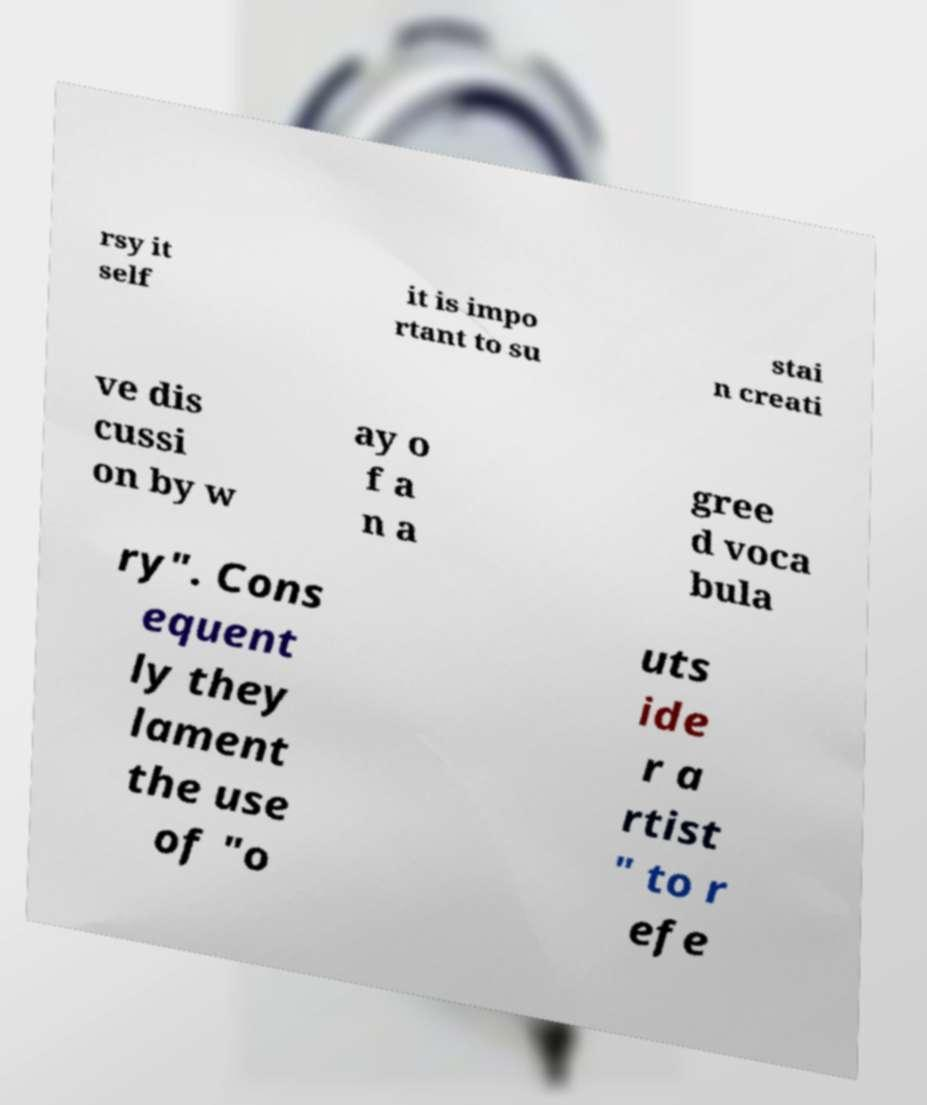What messages or text are displayed in this image? I need them in a readable, typed format. rsy it self it is impo rtant to su stai n creati ve dis cussi on by w ay o f a n a gree d voca bula ry". Cons equent ly they lament the use of "o uts ide r a rtist " to r efe 